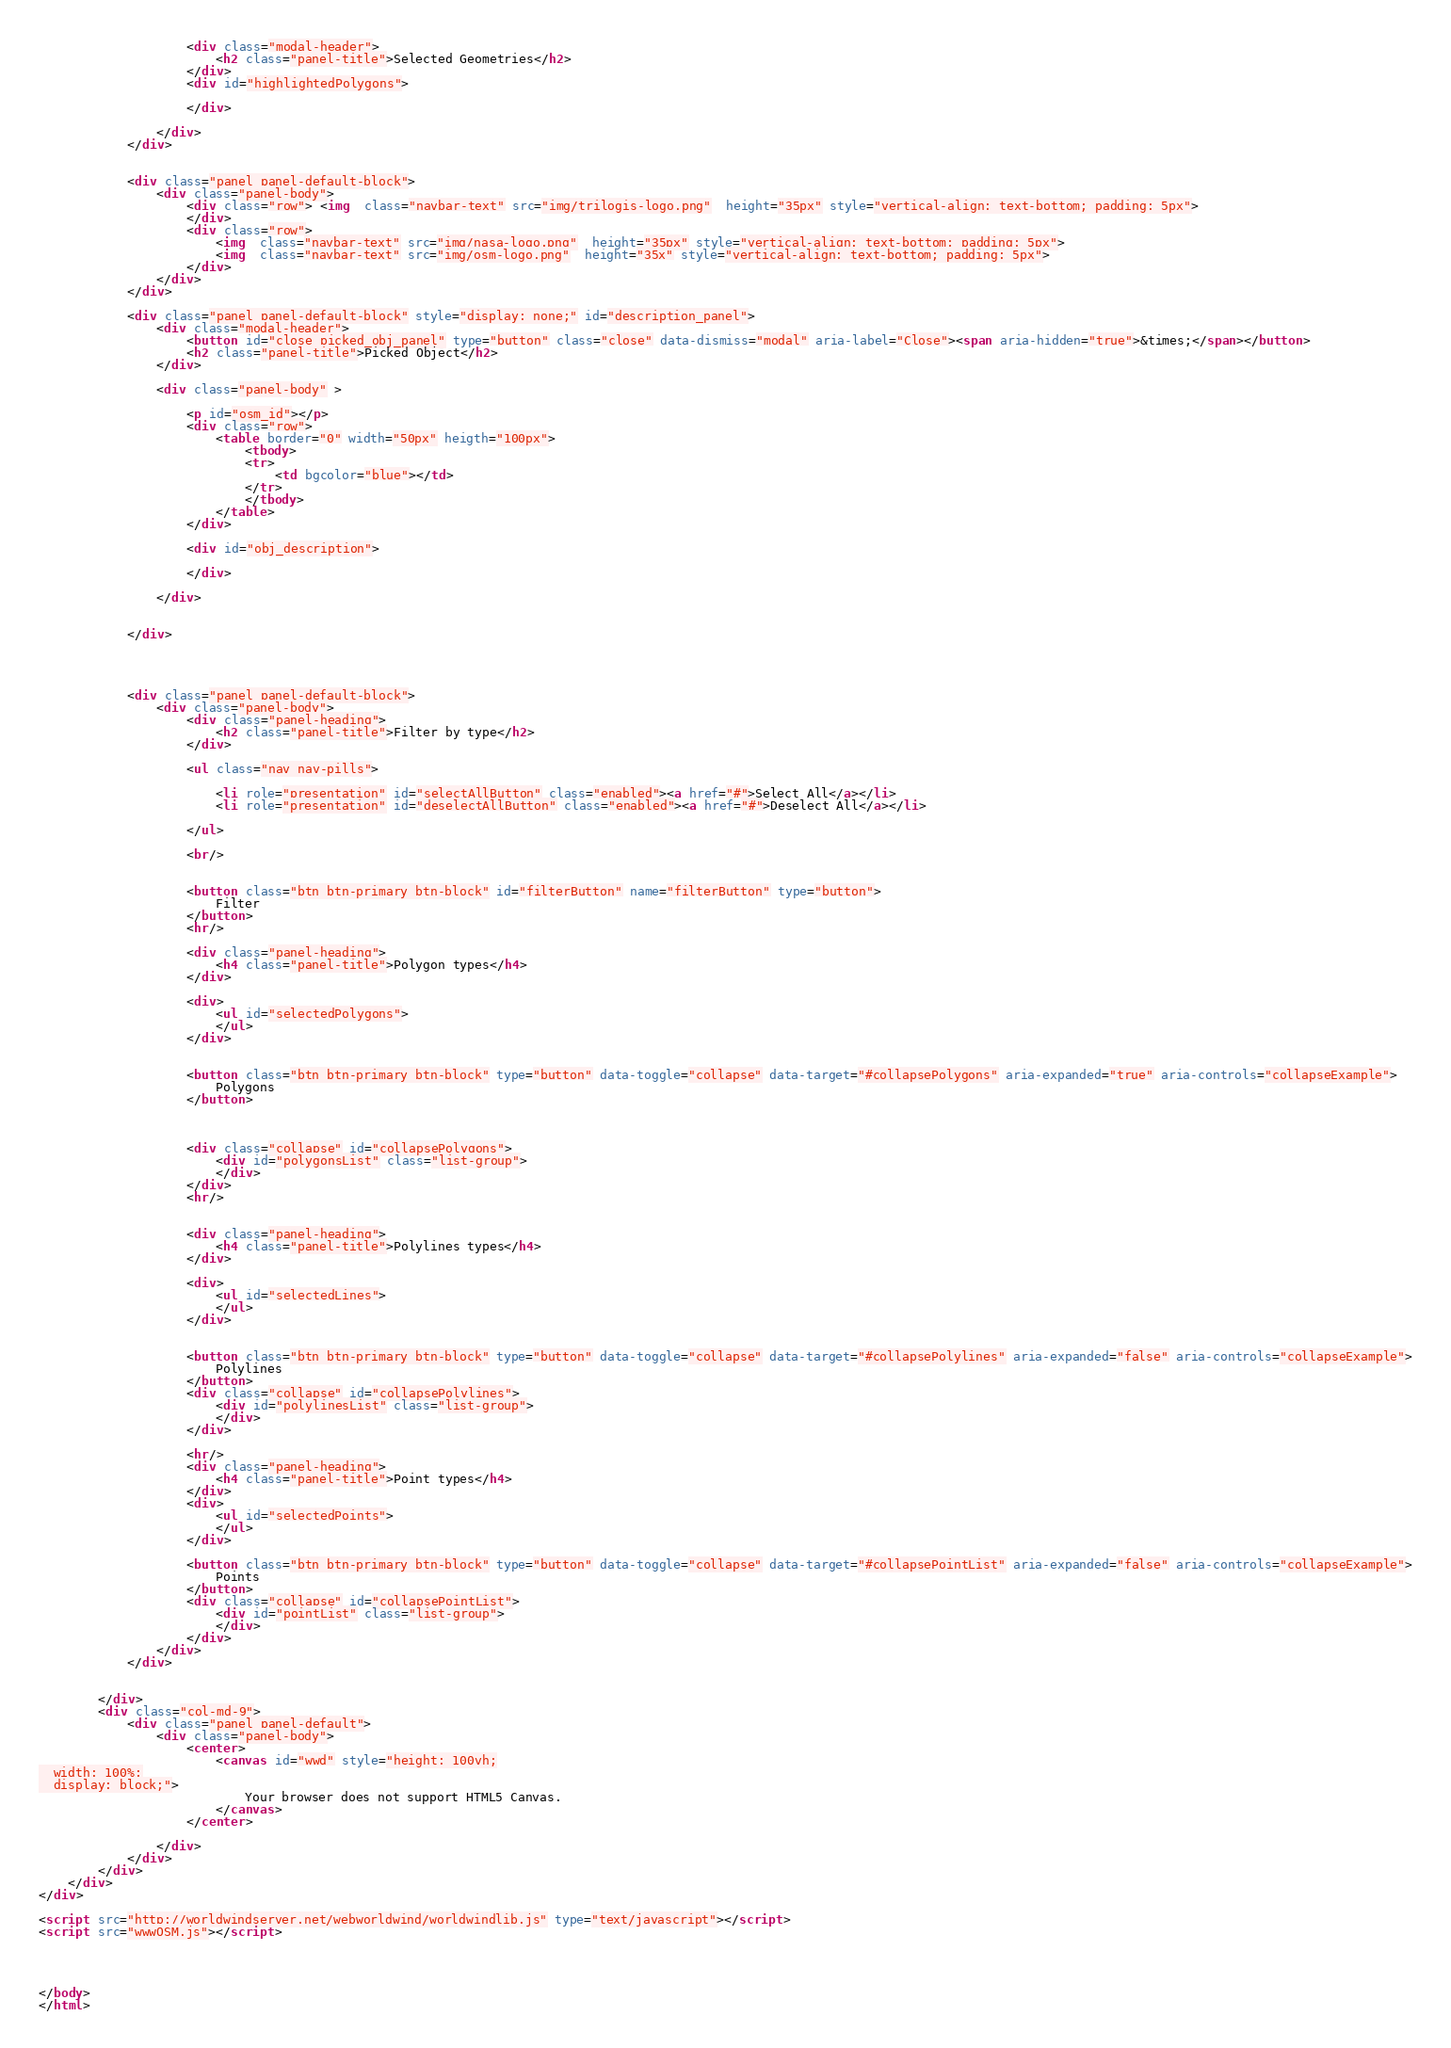Convert code to text. <code><loc_0><loc_0><loc_500><loc_500><_HTML_>                    <div class="modal-header">
                        <h2 class="panel-title">Selected Geometries</h2>
                    </div>
                    <div id="highlightedPolygons">

                    </div>

                </div>
            </div>


            <div class="panel panel-default-block">
                <div class="panel-body">
                    <div class="row"> <img  class="navbar-text" src="img/trilogis-logo.png"  height="35px" style="vertical-align: text-bottom; padding: 5px">
                    </div>
                    <div class="row">
                        <img  class="navbar-text" src="img/nasa-logo.png"  height="35px" style="vertical-align: text-bottom; padding: 5px">
                        <img  class="navbar-text" src="img/osm-logo.png"  height="35x" style="vertical-align: text-bottom; padding: 5px">
                    </div>
                </div>
            </div>

            <div class="panel panel-default-block" style="display: none;" id="description_panel">
                <div class="modal-header">
                    <button id="close_picked_obj_panel" type="button" class="close" data-dismiss="modal" aria-label="Close"><span aria-hidden="true">&times;</span></button>
                    <h2 class="panel-title">Picked Object</h2>
                </div>

                <div class="panel-body" >

                    <p id="osm_id"></p>
                    <div class="row">
                        <table border="0" width="50px" heigth="100px">
                            <tbody>
                            <tr>
                                <td bgcolor="blue"></td>
                            </tr>
                            </tbody>
                        </table>
                    </div>

                    <div id="obj_description">

                    </div>

                </div>


            </div>




            <div class="panel panel-default-block">
                <div class="panel-body">
                    <div class="panel-heading">
                        <h2 class="panel-title">Filter by type</h2>
                    </div>

                    <ul class="nav nav-pills">

                        <li role="presentation" id="selectAllButton" class="enabled"><a href="#">Select All</a></li>
                        <li role="presentation" id="deselectAllButton" class="enabled"><a href="#">Deselect All</a></li>

                    </ul>

                    <br/>


                    <button class="btn btn-primary btn-block" id="filterButton" name="filterButton" type="button">
                        Filter
                    </button>
                    <hr/>

                    <div class="panel-heading">
                        <h4 class="panel-title">Polygon types</h4>
                    </div>

                    <div>
                        <ul id="selectedPolygons">
                        </ul>
                    </div>


                    <button class="btn btn-primary btn-block" type="button" data-toggle="collapse" data-target="#collapsePolygons" aria-expanded="true" aria-controls="collapseExample">
                        Polygons
                    </button>



                    <div class="collapse" id="collapsePolygons">
                        <div id="polygonsList" class="list-group">
                        </div>
                    </div>
                    <hr/>


                    <div class="panel-heading">
                        <h4 class="panel-title">Polylines types</h4>
                    </div>

                    <div>
                        <ul id="selectedLines">
                        </ul>
                    </div>


                    <button class="btn btn-primary btn-block" type="button" data-toggle="collapse" data-target="#collapsePolylines" aria-expanded="false" aria-controls="collapseExample">
                        Polylines
                    </button>
                    <div class="collapse" id="collapsePolylines">
                        <div id="polylinesList" class="list-group">
                        </div>
                    </div>

                    <hr/>
                    <div class="panel-heading">
                        <h4 class="panel-title">Point types</h4>
                    </div>
                    <div>
                        <ul id="selectedPoints">
                        </ul>
                    </div>

                    <button class="btn btn-primary btn-block" type="button" data-toggle="collapse" data-target="#collapsePointList" aria-expanded="false" aria-controls="collapseExample">
                        Points
                    </button>
                    <div class="collapse" id="collapsePointList">
                        <div id="pointList" class="list-group">
                        </div>
                    </div>
                </div>
            </div>


        </div>
        <div class="col-md-9">
            <div class="panel panel-default">
                <div class="panel-body">
                    <center>
                        <canvas id="wwd" style="height: 100vh;
  width: 100%;
  display: block;">
                            Your browser does not support HTML5 Canvas.
                        </canvas>
                    </center>

                </div>
            </div>
        </div>
    </div>
</div>

<script src="http://worldwindserver.net/webworldwind/worldwindlib.js" type="text/javascript"></script>
<script src="wwwOSM.js"></script>




</body>
</html></code> 